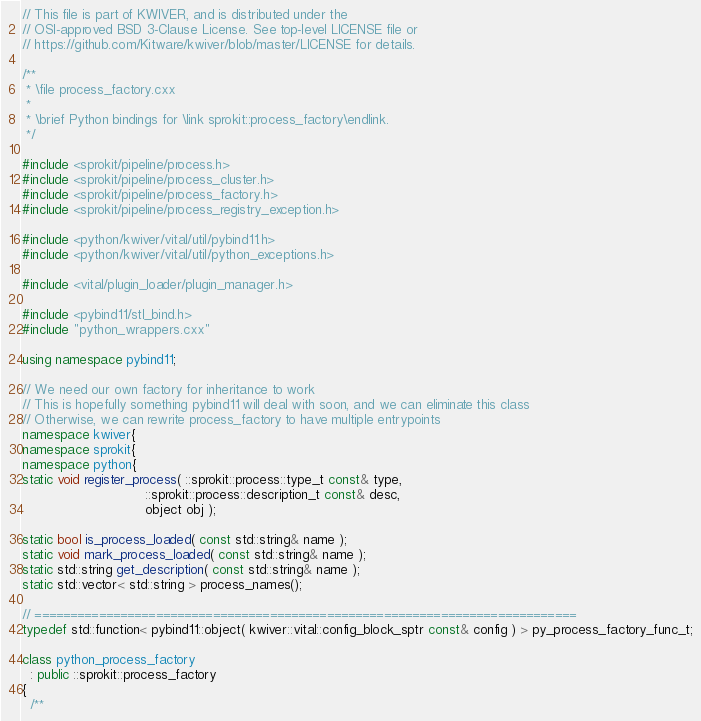<code> <loc_0><loc_0><loc_500><loc_500><_C++_>// This file is part of KWIVER, and is distributed under the
// OSI-approved BSD 3-Clause License. See top-level LICENSE file or
// https://github.com/Kitware/kwiver/blob/master/LICENSE for details.

/**
 * \file process_factory.cxx
 *
 * \brief Python bindings for \link sprokit::process_factory\endlink.
 */

#include <sprokit/pipeline/process.h>
#include <sprokit/pipeline/process_cluster.h>
#include <sprokit/pipeline/process_factory.h>
#include <sprokit/pipeline/process_registry_exception.h>

#include <python/kwiver/vital/util/pybind11.h>
#include <python/kwiver/vital/util/python_exceptions.h>

#include <vital/plugin_loader/plugin_manager.h>

#include <pybind11/stl_bind.h>
#include "python_wrappers.cxx"

using namespace pybind11;

// We need our own factory for inheritance to work
// This is hopefully something pybind11 will deal with soon, and we can eliminate this class
// Otherwise, we can rewrite process_factory to have multiple entrypoints
namespace kwiver{
namespace sprokit{
namespace python{
static void register_process( ::sprokit::process::type_t const& type,
                              ::sprokit::process::description_t const& desc,
                              object obj );

static bool is_process_loaded( const std::string& name );
static void mark_process_loaded( const std::string& name );
static std::string get_description( const std::string& name );
static std::vector< std::string > process_names();

// ============================================================================
typedef std::function< pybind11::object( kwiver::vital::config_block_sptr const& config ) > py_process_factory_func_t;

class python_process_factory
  : public ::sprokit::process_factory
{
  /**</code> 